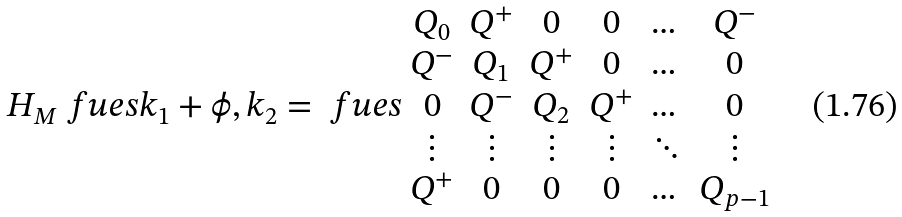<formula> <loc_0><loc_0><loc_500><loc_500>H _ { M } \ f u e s { k _ { 1 } + \phi , k _ { 2 } } = \ f u e s { \begin{array} { c c c c c c c c } Q _ { 0 } & Q ^ { + } & 0 & 0 & \dots & Q ^ { - } \\ Q ^ { - } & Q _ { 1 } & Q ^ { + } & 0 & \dots & 0 \\ 0 & Q ^ { - } & Q _ { 2 } & Q ^ { + } & \dots & 0 \\ \vdots & \vdots & \vdots & \vdots & \ddots & \vdots \\ Q ^ { + } & 0 & 0 & 0 & \dots & Q _ { p - 1 } \\ \end{array} }</formula> 